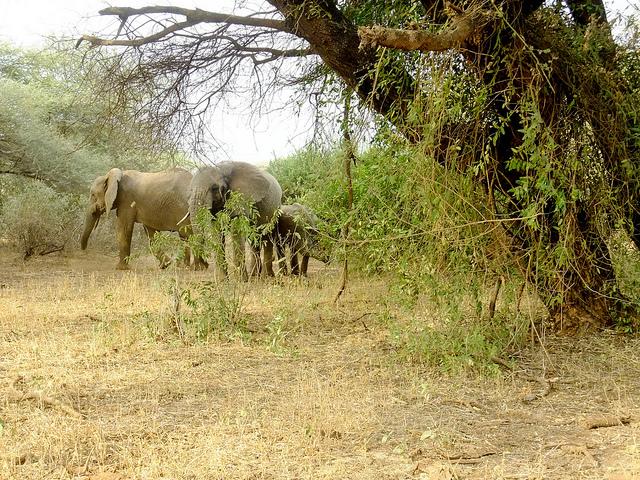Is there any water?
Concise answer only. No. Is the tree on the right leaning?
Give a very brief answer. Yes. Where are the animals grazing?
Answer briefly. Field. Does the grass look dead?
Concise answer only. Yes. How many elephants are there?
Quick response, please. 3. Are the elephants looking for food?
Concise answer only. Yes. 